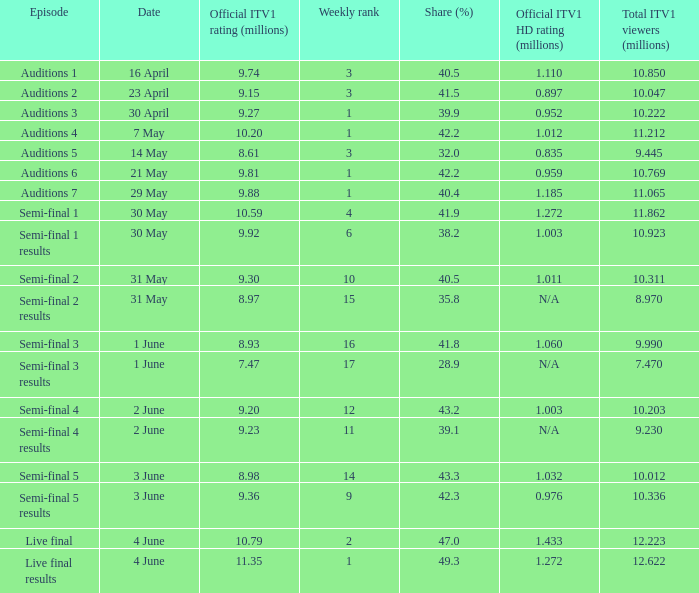9% share? 7.47. 